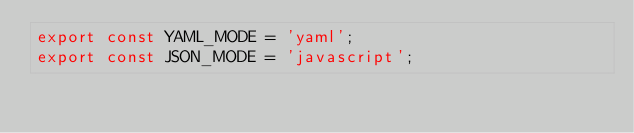<code> <loc_0><loc_0><loc_500><loc_500><_JavaScript_>export const YAML_MODE = 'yaml';
export const JSON_MODE = 'javascript';
</code> 